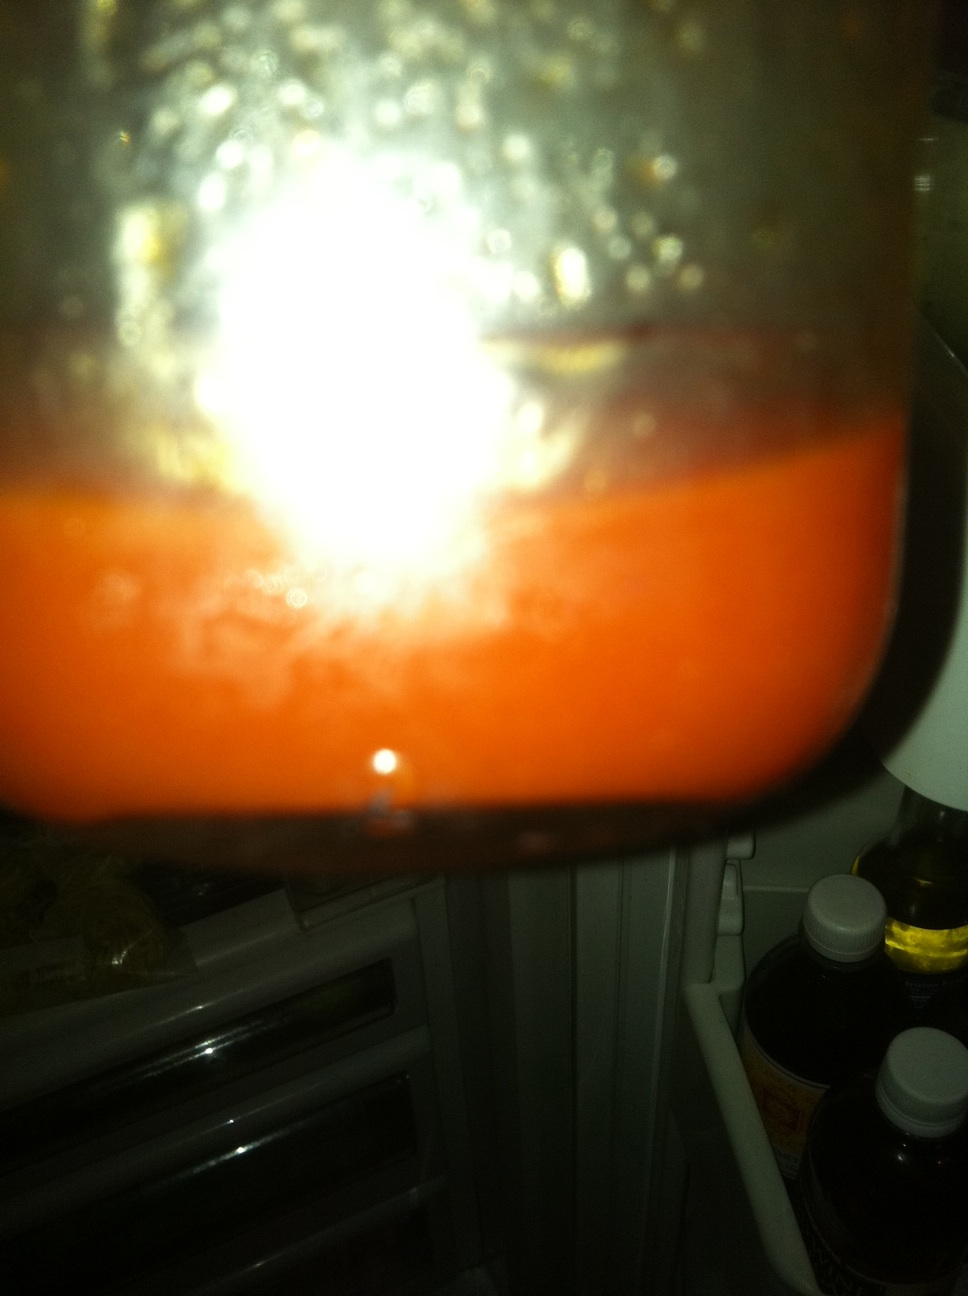What bottle is this? What dressing is it? Thank you. From the image provided, it's difficult to determine the specific type of bottle or the dressing precisely due to the picture's focus and lighting conditions. The content appears to be a type of dressing or sauce, perhaps homemade, with a reddish-orange color, commonly seen in tomato-based or peppered dressings. For a definitive answer, clearer imagery or additional context would be necessary. 